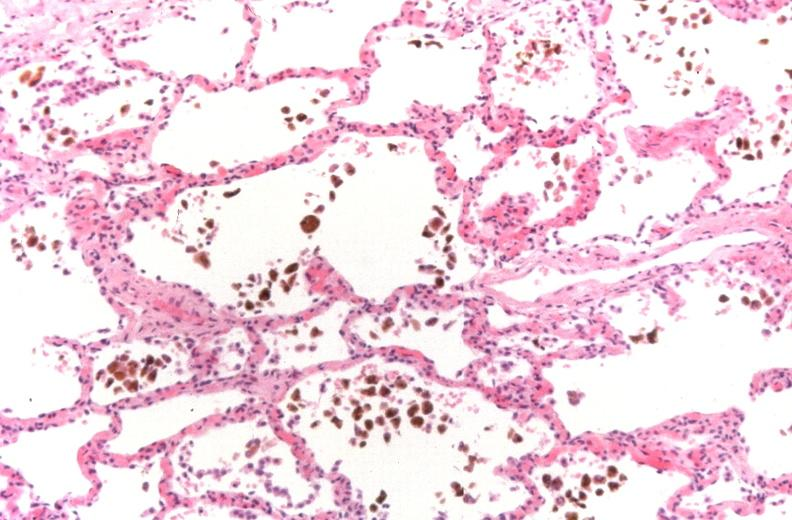does this image show lung, congestion, heart failure cells hemosiderin laden macrophages?
Answer the question using a single word or phrase. Yes 